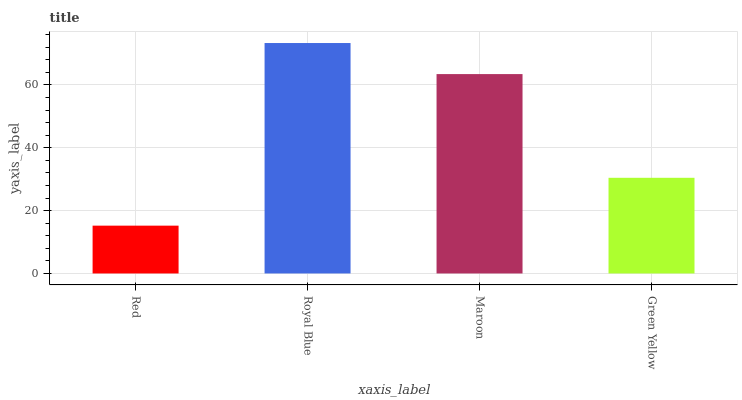Is Red the minimum?
Answer yes or no. Yes. Is Royal Blue the maximum?
Answer yes or no. Yes. Is Maroon the minimum?
Answer yes or no. No. Is Maroon the maximum?
Answer yes or no. No. Is Royal Blue greater than Maroon?
Answer yes or no. Yes. Is Maroon less than Royal Blue?
Answer yes or no. Yes. Is Maroon greater than Royal Blue?
Answer yes or no. No. Is Royal Blue less than Maroon?
Answer yes or no. No. Is Maroon the high median?
Answer yes or no. Yes. Is Green Yellow the low median?
Answer yes or no. Yes. Is Royal Blue the high median?
Answer yes or no. No. Is Royal Blue the low median?
Answer yes or no. No. 